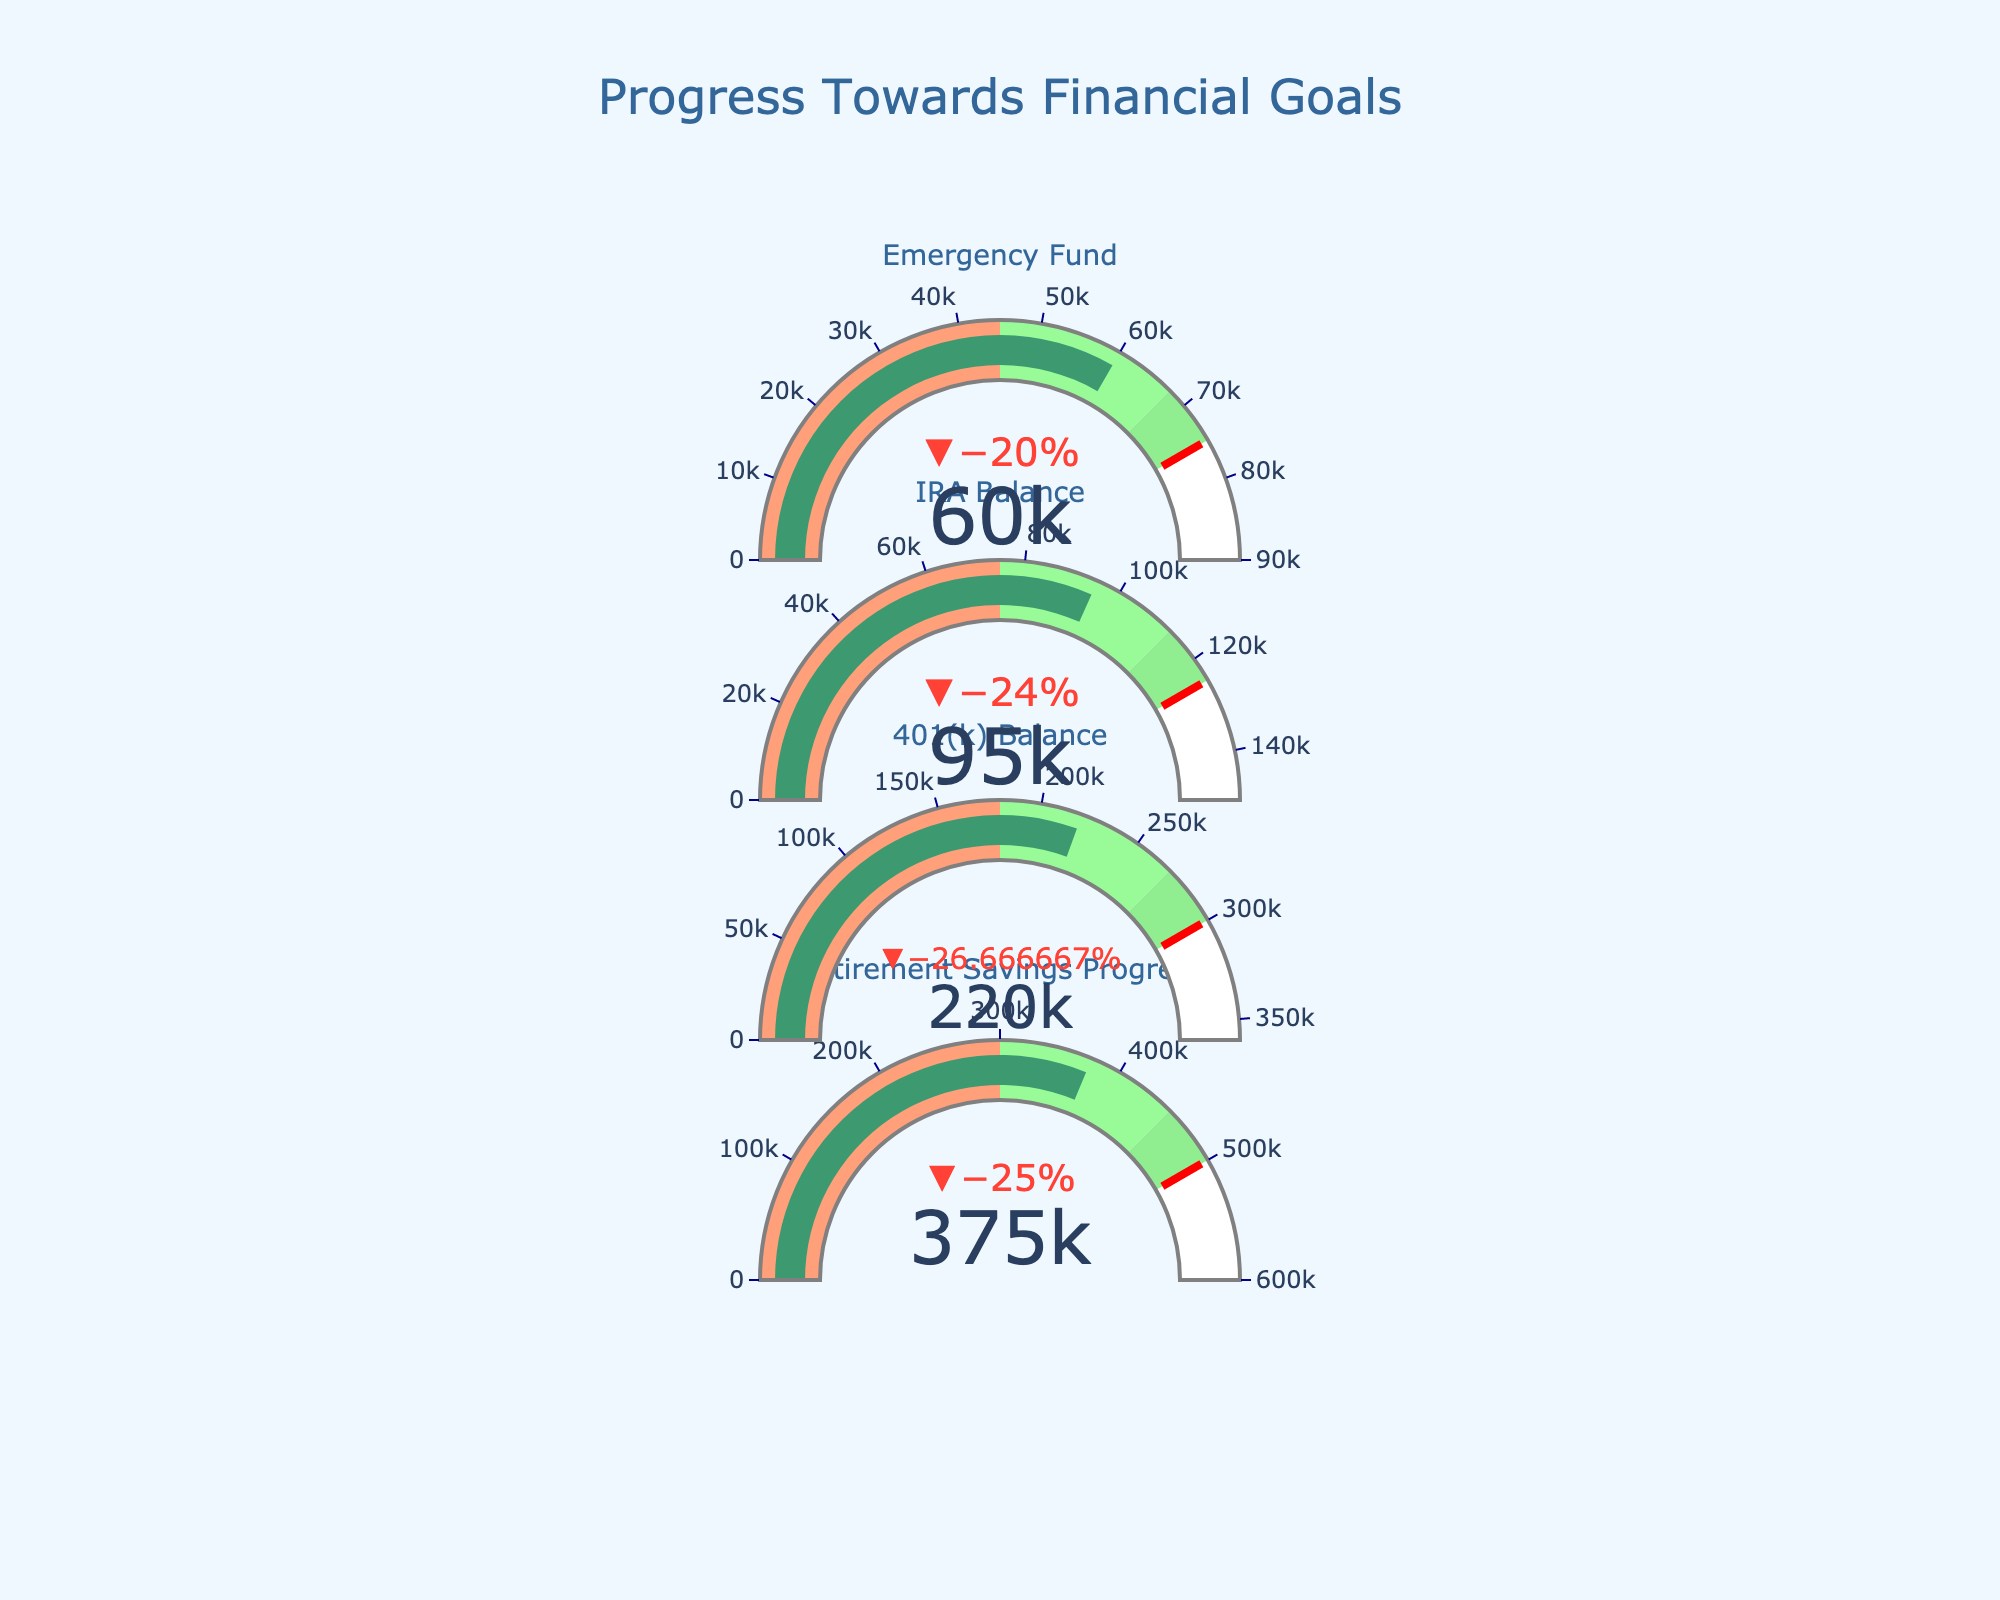What's the title of the chart? The title is prominently displayed at the top of the chart. It reads "Progress Towards Financial Goals".
Answer: Progress Towards Financial Goals What is the target for Retirement Savings Progress? The gauge for Retirement Savings Progress clearly marks its target value with a line and label. The target is set at $500,000.
Answer: $500,000 What is the difference between the actual 401(k) Balance and its target? The actual 401(k) Balance is $220,000 and the target is $300,000. The difference is calculated as $300,000 - $220,000.
Answer: $80,000 How many areas are there in the gauge for the IRA Balance, and what do they represent? The gauge for the IRA Balance is divided into four areas, each with a different color. These areas represent Poor (0-$75,000), Satisfactory ($75,000-$112,500), Good ($112,500-$125,000), and above target.
Answer: Four areas Which savings category is the closest to reaching its target, and how do you know? By inspecting the values and positions of the indicators, the Emergency Fund is closest to its target, with $60,000 out of a $75,000 target. The indicator bar is close to the red threshold marker at $75,000.
Answer: Emergency Fund Are any of the savings categories within the Good range? If so, which ones? The 401(k) Balance and Emergency Fund both fall within the Good range on their respective gauges, indicated by their positions within the green sections that are labeled as Good.
Answer: 401(k) Balance, Emergency Fund What percentage of the target has been achieved for the Retirement Savings Progress? The Retirement Savings Progress target is $500,000, and the actual value is $375,000. The percentage achieved is calculated as ($375,000 / $500,000) * 100.
Answer: 75% How much more is needed to reach the Satisfactory range in IRA Balance? The actual IRA Balance is $95,000. The Satisfactory range starts at $75,000 and ends at $112,500. Subtracting $95,000 from $112,500 gives the needed addition.
Answer: $17,500 Which saving category has the highest actual value? By comparing the actual values displayed on each gauge, the Retirement Savings Progress has the highest actual value at $375,000.
Answer: Retirement Savings Progress Is any category in the Poor range? By inspecting the positions of the indicators and their ranges, none of the categories fall within the Poor range of their respective gauges.
Answer: No 